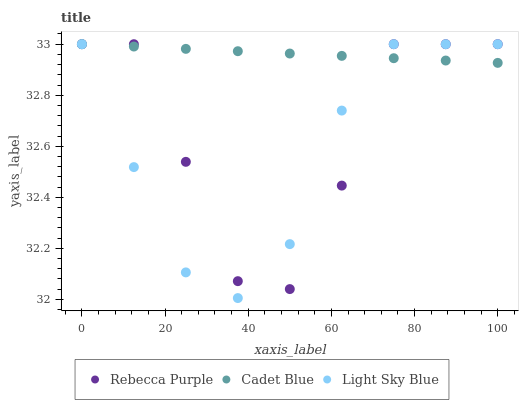Does Light Sky Blue have the minimum area under the curve?
Answer yes or no. Yes. Does Cadet Blue have the maximum area under the curve?
Answer yes or no. Yes. Does Rebecca Purple have the minimum area under the curve?
Answer yes or no. No. Does Rebecca Purple have the maximum area under the curve?
Answer yes or no. No. Is Cadet Blue the smoothest?
Answer yes or no. Yes. Is Rebecca Purple the roughest?
Answer yes or no. Yes. Is Light Sky Blue the smoothest?
Answer yes or no. No. Is Light Sky Blue the roughest?
Answer yes or no. No. Does Light Sky Blue have the lowest value?
Answer yes or no. Yes. Does Rebecca Purple have the lowest value?
Answer yes or no. No. Does Light Sky Blue have the highest value?
Answer yes or no. Yes. Does Cadet Blue intersect Light Sky Blue?
Answer yes or no. Yes. Is Cadet Blue less than Light Sky Blue?
Answer yes or no. No. Is Cadet Blue greater than Light Sky Blue?
Answer yes or no. No. 